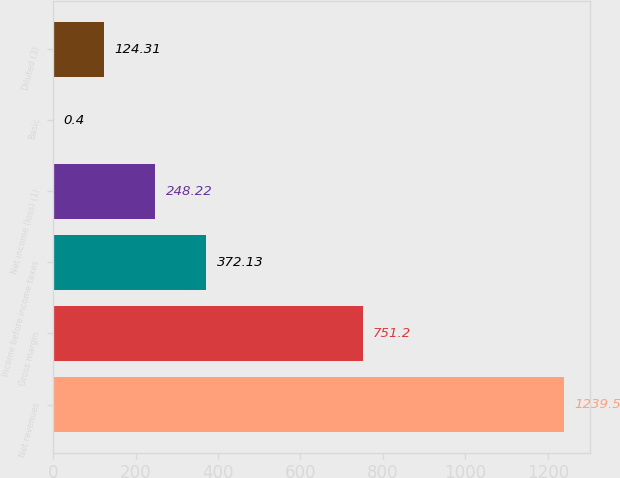<chart> <loc_0><loc_0><loc_500><loc_500><bar_chart><fcel>Net revenues<fcel>Gross margin<fcel>Income before income taxes<fcel>Net income (loss) (1)<fcel>Basic<fcel>Diluted (3)<nl><fcel>1239.5<fcel>751.2<fcel>372.13<fcel>248.22<fcel>0.4<fcel>124.31<nl></chart> 